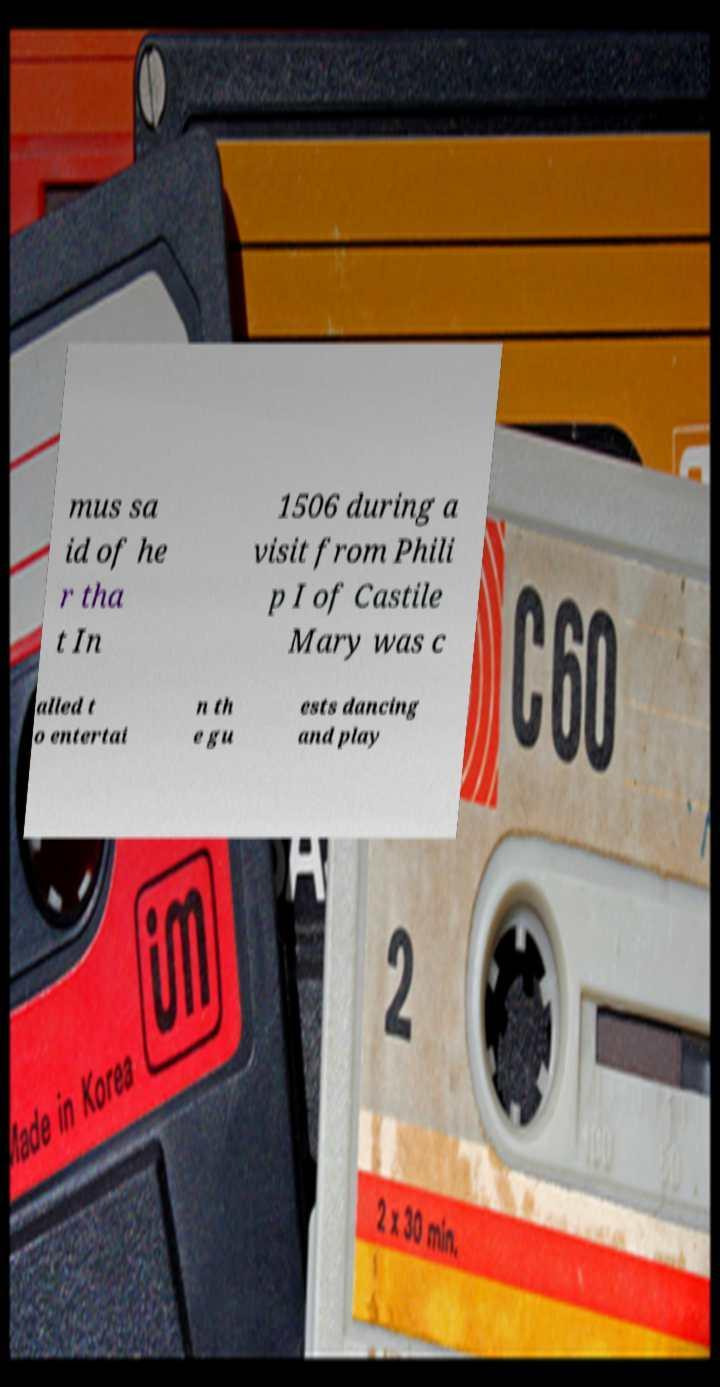I need the written content from this picture converted into text. Can you do that? mus sa id of he r tha t In 1506 during a visit from Phili p I of Castile Mary was c alled t o entertai n th e gu ests dancing and play 